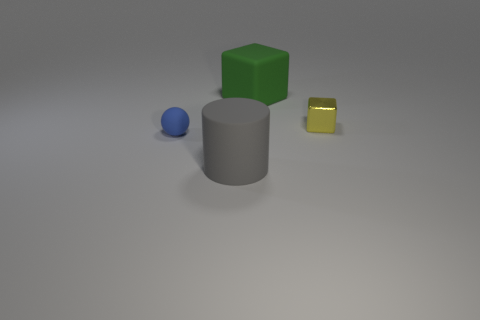Is there any other thing that has the same material as the yellow object?
Make the answer very short. No. Is the number of tiny things in front of the small yellow object greater than the number of big gray things that are behind the big green rubber block?
Make the answer very short. Yes. There is a thing that is behind the big gray rubber cylinder and in front of the tiny yellow block; what size is it?
Provide a succinct answer. Small. How many other yellow shiny blocks are the same size as the shiny block?
Your answer should be very brief. 0. Does the large matte thing behind the gray matte cylinder have the same shape as the tiny rubber object?
Ensure brevity in your answer.  No. Is the number of yellow metallic things behind the green rubber thing less than the number of green balls?
Give a very brief answer. No. There is a small shiny thing; does it have the same shape as the large thing that is on the right side of the gray cylinder?
Make the answer very short. Yes. Are there any large cubes that have the same material as the ball?
Ensure brevity in your answer.  Yes. Is there a large thing behind the thing on the left side of the thing in front of the small matte object?
Ensure brevity in your answer.  Yes. What number of other things are the same shape as the small rubber thing?
Ensure brevity in your answer.  0. 